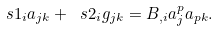<formula> <loc_0><loc_0><loc_500><loc_500>\ s { 1 } _ { i } a _ { j k } + \ s { 2 } _ { i } g _ { j k } = B _ { , i } a ^ { p } _ { j } a _ { p k } .</formula> 